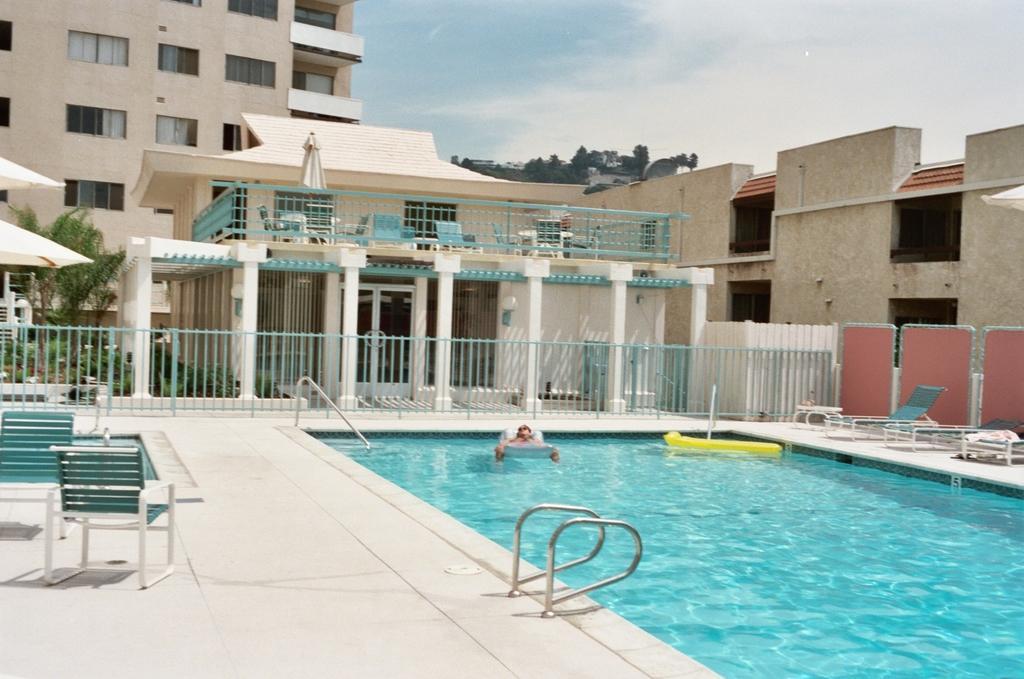Can you describe this image briefly? In the background of the image there is a building, sky, trees. At the bottom of the image there is a swimming pool. There are chairs. There is a metal railing. 